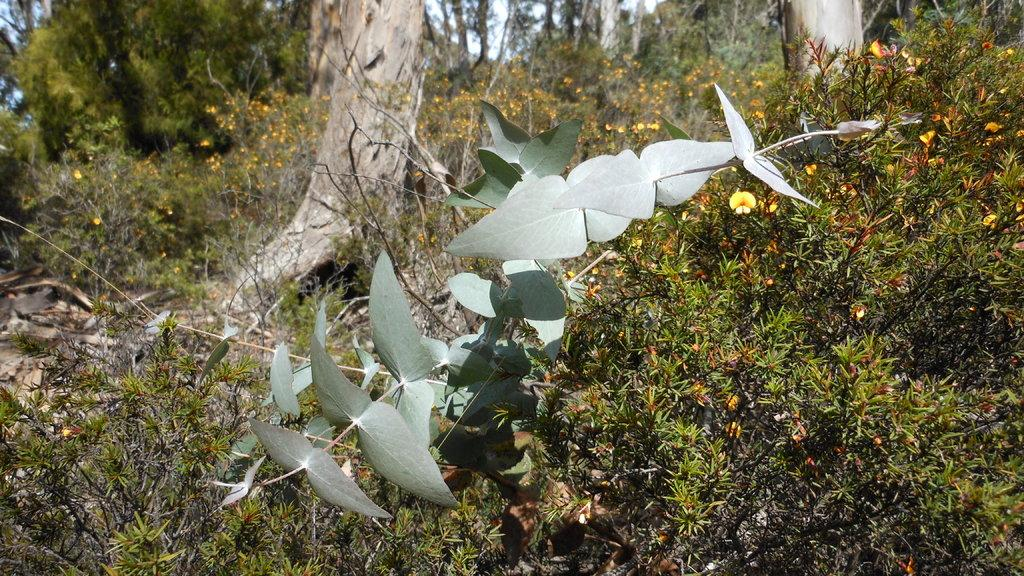What is the person in the image doing near the fireplace? The person is standing near the fireplace. What can be seen on the wall above the fireplace? There is a painting on the wall above the fireplace. What type of skirt is the person wearing in the image? The image does not show the person wearing a skirt, so it cannot be determined from the image. 